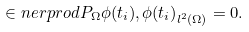Convert formula to latex. <formula><loc_0><loc_0><loc_500><loc_500>\in n e r p r o d { P _ { \Omega } \phi ( t _ { i } ) , \phi ( t _ { i } ) } _ { l ^ { 2 } ( \Omega ) } = 0 .</formula> 